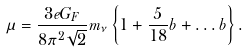<formula> <loc_0><loc_0><loc_500><loc_500>\mu = { \frac { 3 e G _ { F } } { 8 \pi ^ { 2 } \sqrt { 2 } } } m _ { \nu } \left \{ 1 + { \frac { 5 } { 1 8 } } b + \dots b \right \} .</formula> 